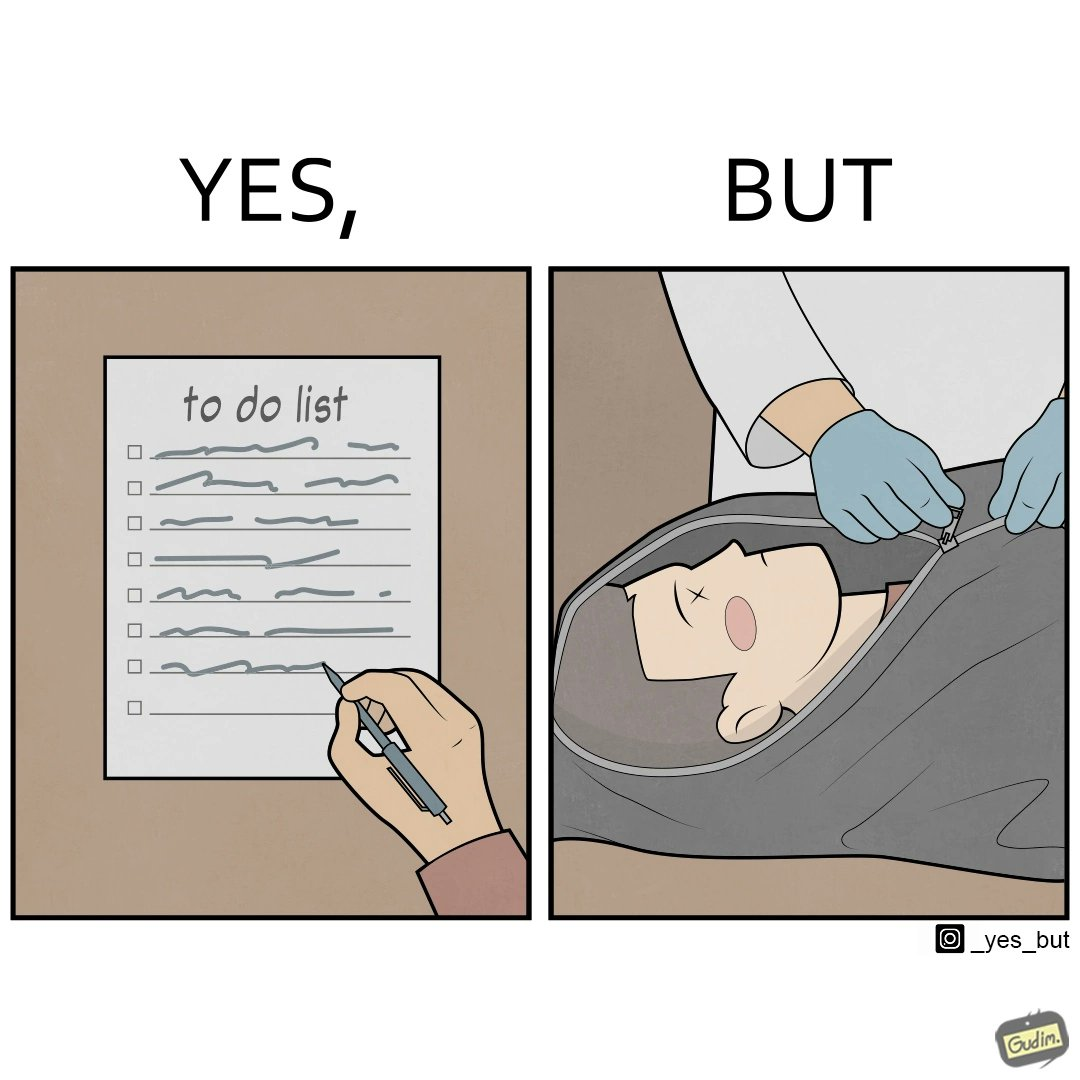Explain the humor or irony in this image. The image is ironic, because in the first image it shows that someone plan their life in a to-do list but as the future is unknown anyone can never be sure whether he/she can complete their to-do lists 